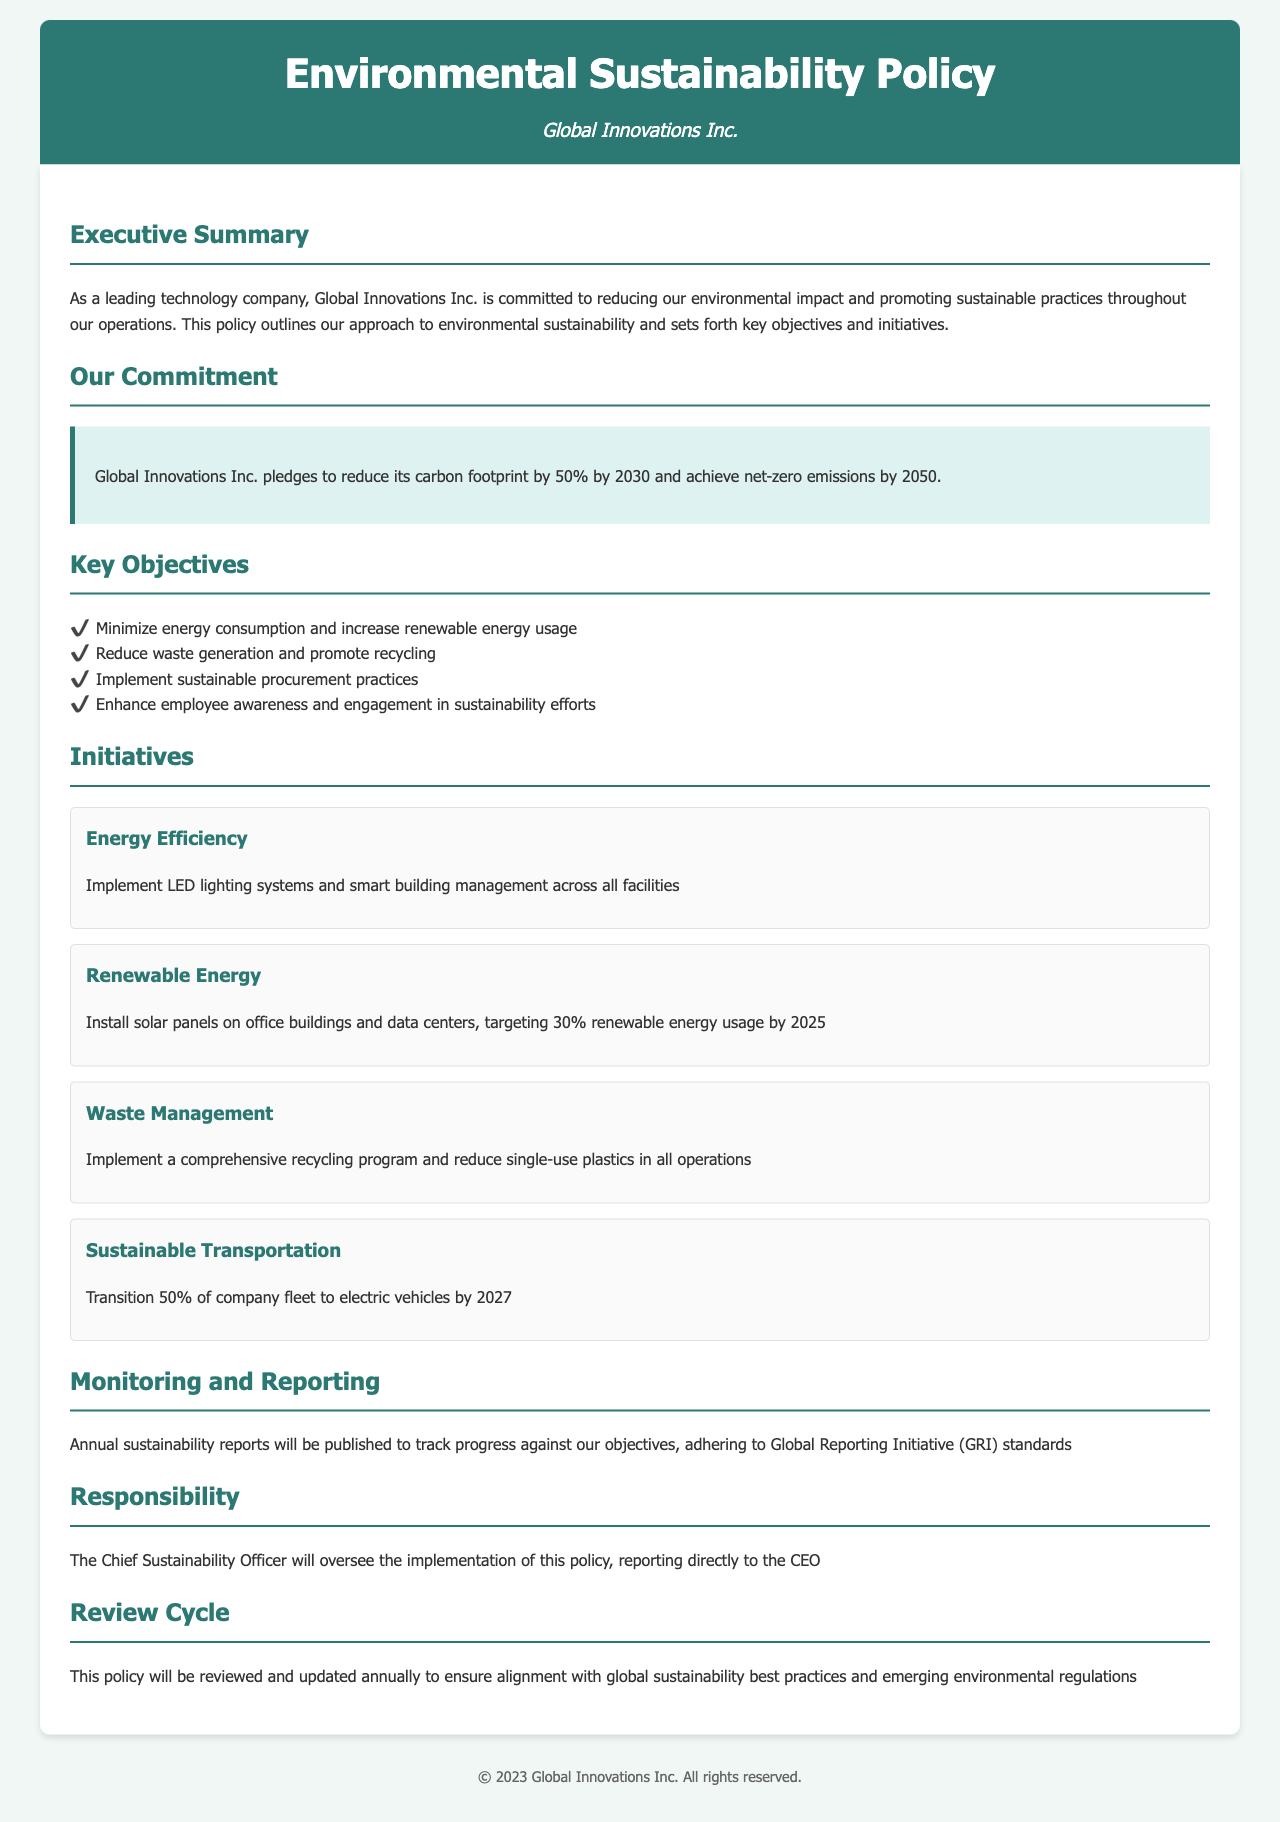What is the company’s carbon footprint reduction target by 2030? The policy states that Global Innovations Inc. pledges to reduce its carbon footprint by 50% by 2030.
Answer: 50% What year does Global Innovations Inc. aim to achieve net-zero emissions? The document indicates that the company seeks to achieve net-zero emissions by 2050.
Answer: 2050 What percentage of renewable energy usage is targeted by 2025? The initiative regarding renewable energy specifies a target of 30% renewable energy usage by 2025.
Answer: 30% Who oversees the implementation of the Environmental Sustainability Policy? The responsibility section clarifies that the Chief Sustainability Officer will oversee the implementation of this policy.
Answer: Chief Sustainability Officer What is one method the company plans to improve energy efficiency? The energy efficiency initiative mentions the implementation of LED lighting systems as a method to improve efficiency.
Answer: LED lighting systems What is the purpose of the annual sustainability reports? The purpose is to track progress against the company's sustainability objectives.
Answer: Track progress How often will the policy be reviewed? The document states that this policy will be reviewed annually to ensure alignment with best practices.
Answer: Annually What is one objective related to waste management? The key objectives include reducing waste generation and promoting recycling.
Answer: Reduce waste generation What is the company’s electric vehicle transition target percentage by 2027? The sustainable transportation initiative specifies a transition of 50% of the company fleet to electric vehicles by 2027.
Answer: 50% 